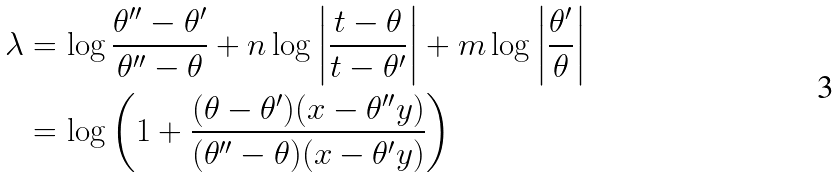Convert formula to latex. <formula><loc_0><loc_0><loc_500><loc_500>\lambda & = \log \frac { \theta ^ { \prime \prime } - \theta ^ { \prime } } { \theta ^ { \prime \prime } - \theta } + n \log \left | \frac { t - \theta } { t - \theta ^ { \prime } } \right | + m \log \left | \frac { \theta ^ { \prime } } { \theta } \right | \\ & = \log \left ( 1 + \frac { ( \theta - \theta ^ { \prime } ) ( x - \theta ^ { \prime \prime } y ) } { ( \theta ^ { \prime \prime } - \theta ) ( x - \theta ^ { \prime } y ) } \right )</formula> 